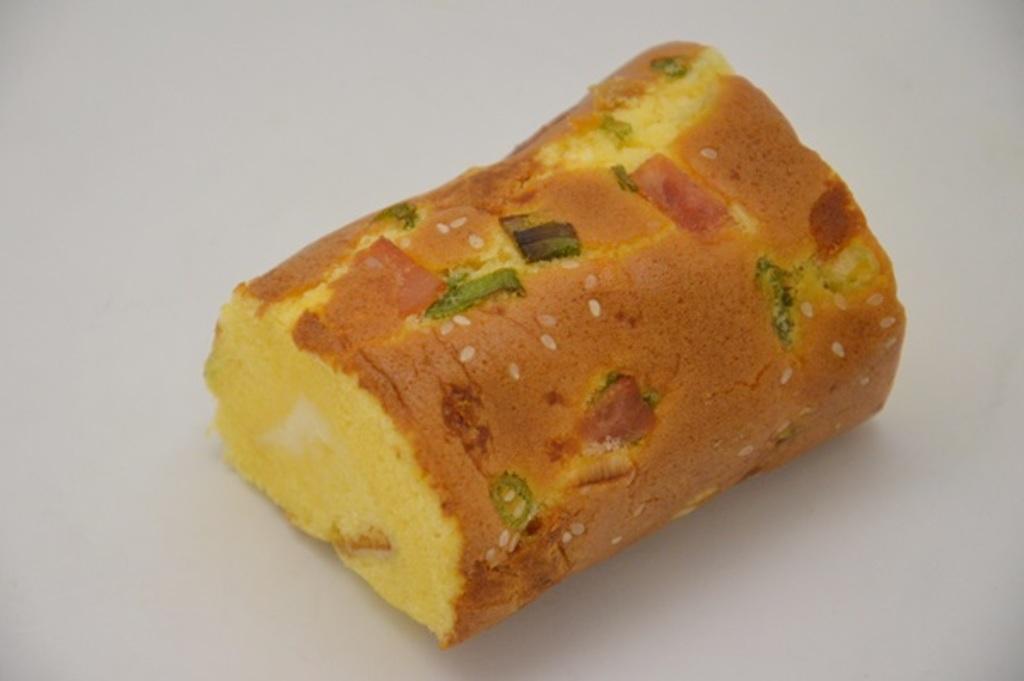How would you summarize this image in a sentence or two? In this image, at the middle there is a brown and yellow color food item and there is a white color background. 